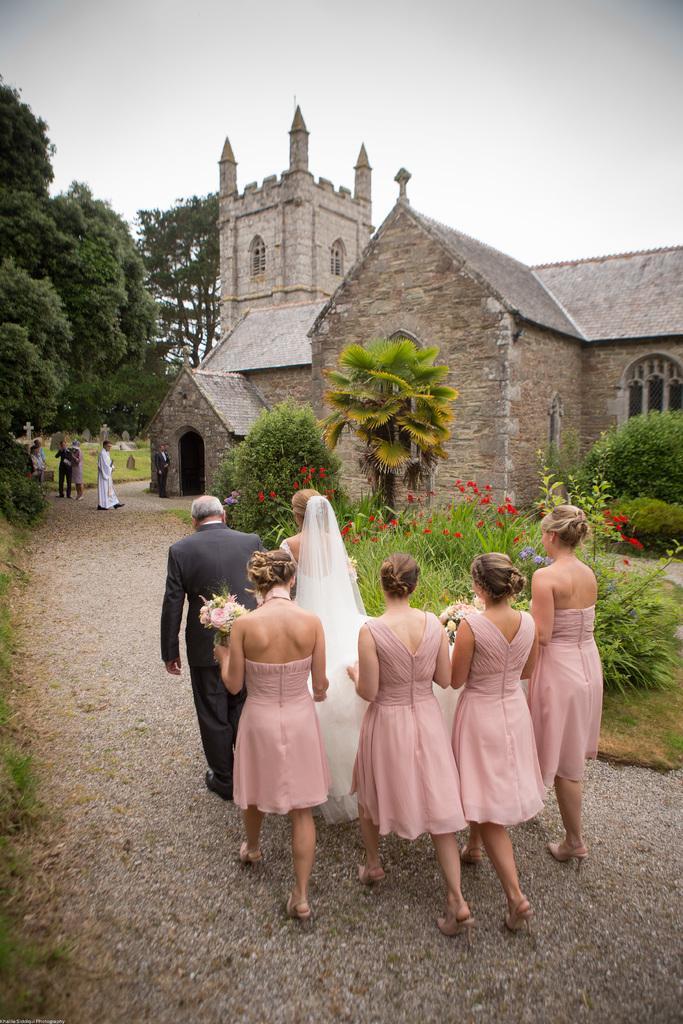Could you give a brief overview of what you see in this image? In front of the image there is a man, bride and a few bridesmaids carrying flowers bouquets are walking towards the church, in front of them there are a few people standing, in the background of the image there are flowers on plants, trees and a church building. 